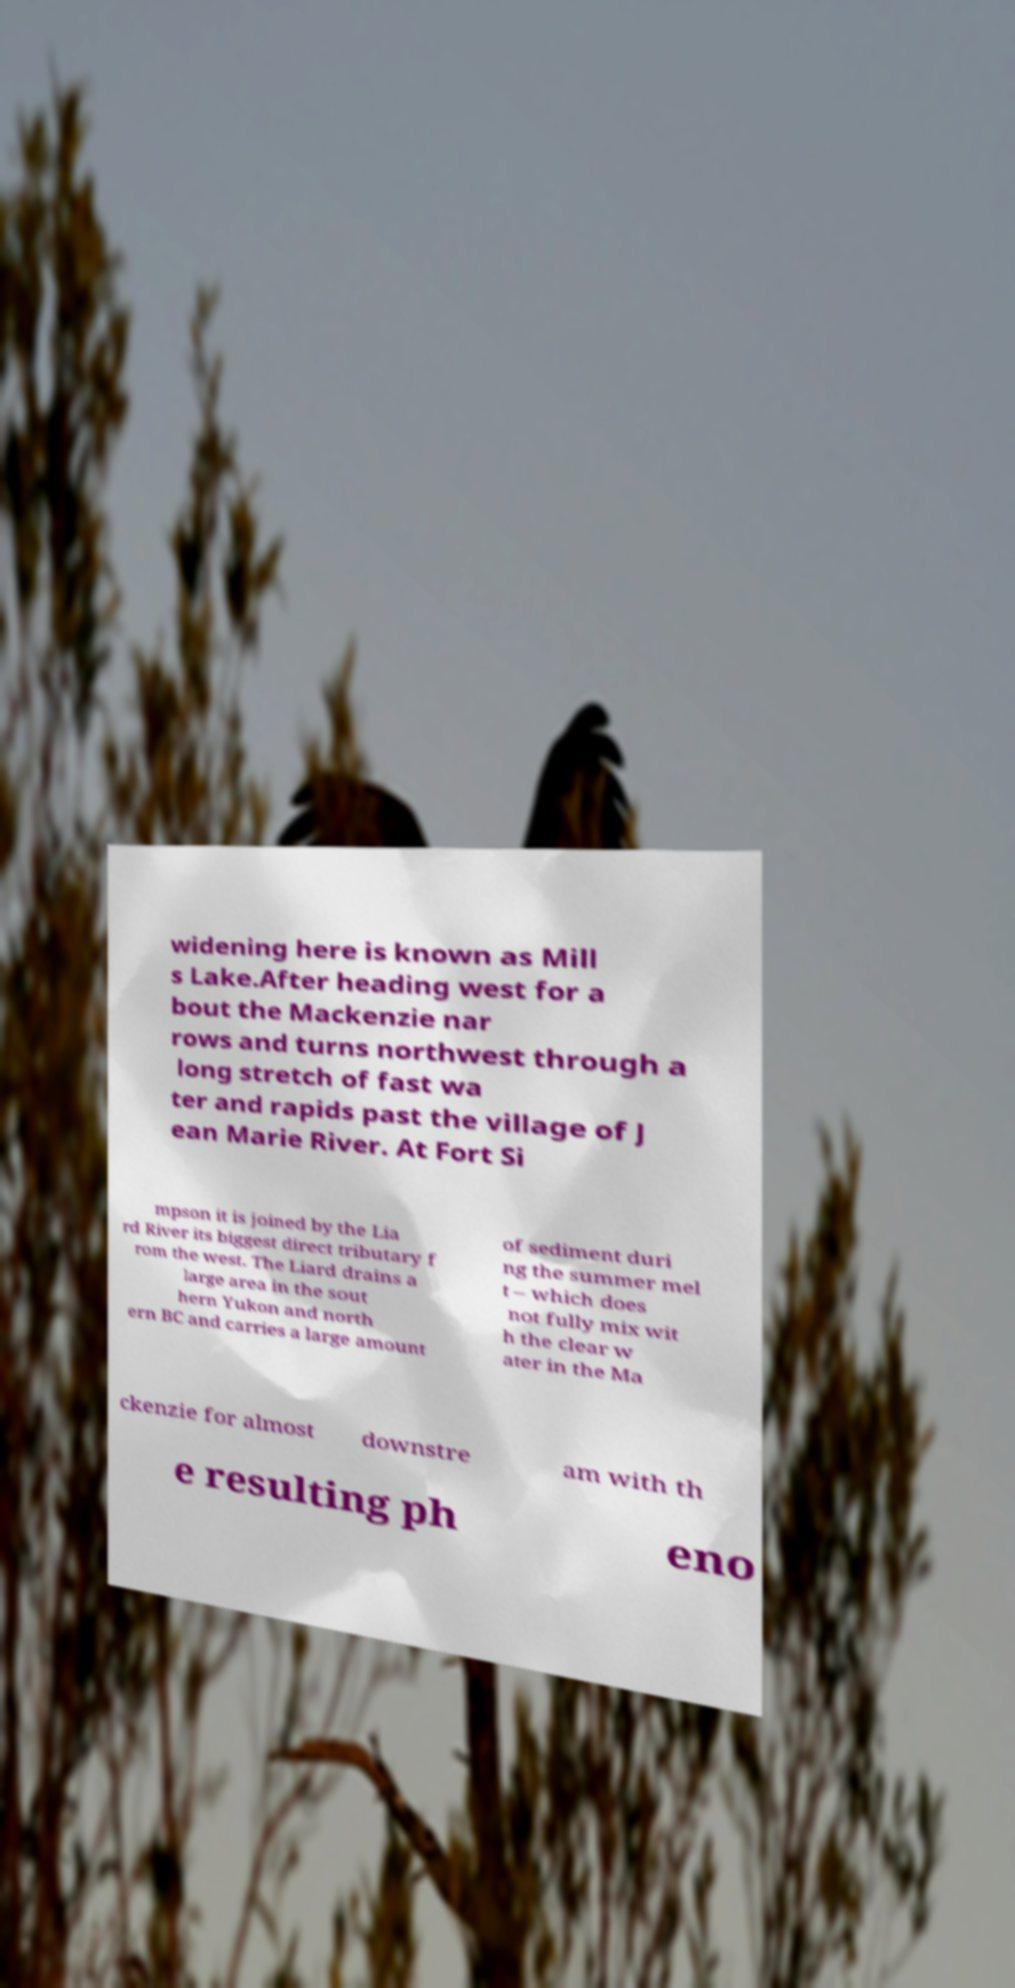Please identify and transcribe the text found in this image. widening here is known as Mill s Lake.After heading west for a bout the Mackenzie nar rows and turns northwest through a long stretch of fast wa ter and rapids past the village of J ean Marie River. At Fort Si mpson it is joined by the Lia rd River its biggest direct tributary f rom the west. The Liard drains a large area in the sout hern Yukon and north ern BC and carries a large amount of sediment duri ng the summer mel t – which does not fully mix wit h the clear w ater in the Ma ckenzie for almost downstre am with th e resulting ph eno 